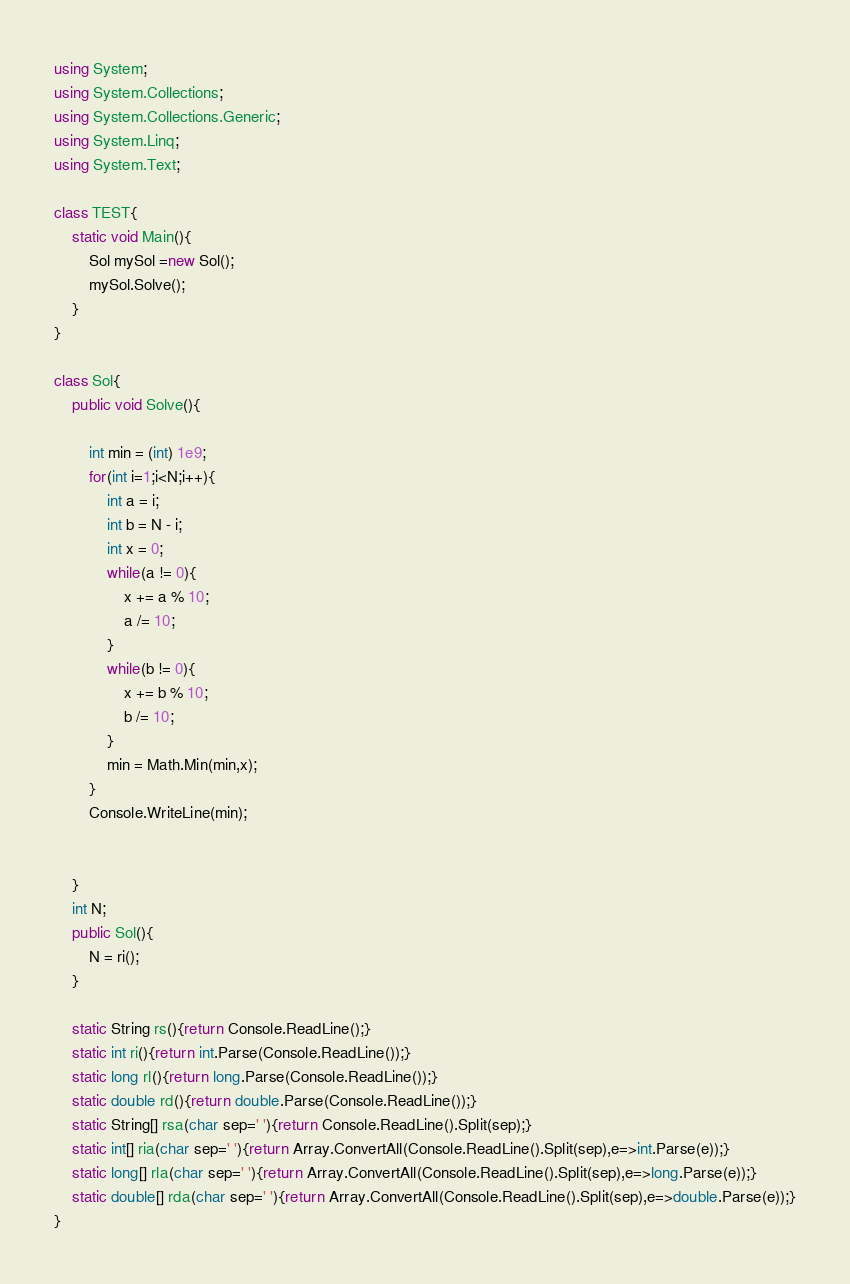<code> <loc_0><loc_0><loc_500><loc_500><_C#_>using System;
using System.Collections;
using System.Collections.Generic;
using System.Linq;
using System.Text;

class TEST{
	static void Main(){
		Sol mySol =new Sol();
		mySol.Solve();
	}
}

class Sol{
	public void Solve(){
		
		int min = (int) 1e9;
		for(int i=1;i<N;i++){
			int a = i;
			int b = N - i;
			int x = 0;
			while(a != 0){
				x += a % 10;
				a /= 10;
			}
			while(b != 0){
				x += b % 10;
				b /= 10;
			}
			min = Math.Min(min,x);
		}
		Console.WriteLine(min);
		
		
	}
	int N;
	public Sol(){
		N = ri();
	}

	static String rs(){return Console.ReadLine();}
	static int ri(){return int.Parse(Console.ReadLine());}
	static long rl(){return long.Parse(Console.ReadLine());}
	static double rd(){return double.Parse(Console.ReadLine());}
	static String[] rsa(char sep=' '){return Console.ReadLine().Split(sep);}
	static int[] ria(char sep=' '){return Array.ConvertAll(Console.ReadLine().Split(sep),e=>int.Parse(e));}
	static long[] rla(char sep=' '){return Array.ConvertAll(Console.ReadLine().Split(sep),e=>long.Parse(e));}
	static double[] rda(char sep=' '){return Array.ConvertAll(Console.ReadLine().Split(sep),e=>double.Parse(e));}
}
</code> 